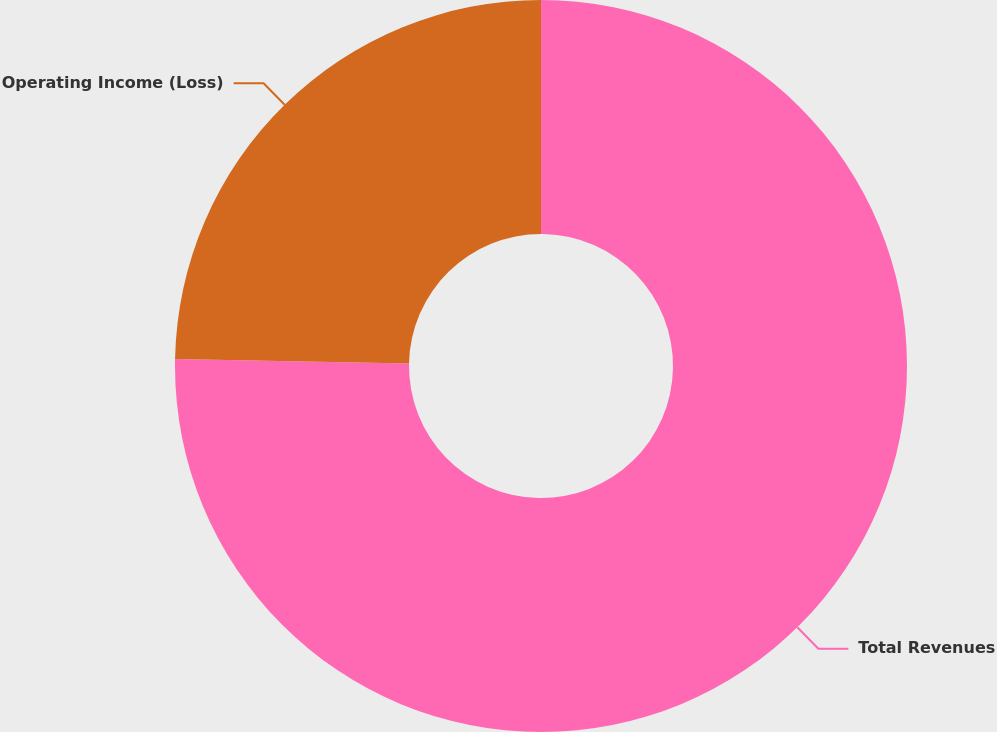<chart> <loc_0><loc_0><loc_500><loc_500><pie_chart><fcel>Total Revenues<fcel>Operating Income (Loss)<nl><fcel>75.3%<fcel>24.7%<nl></chart> 